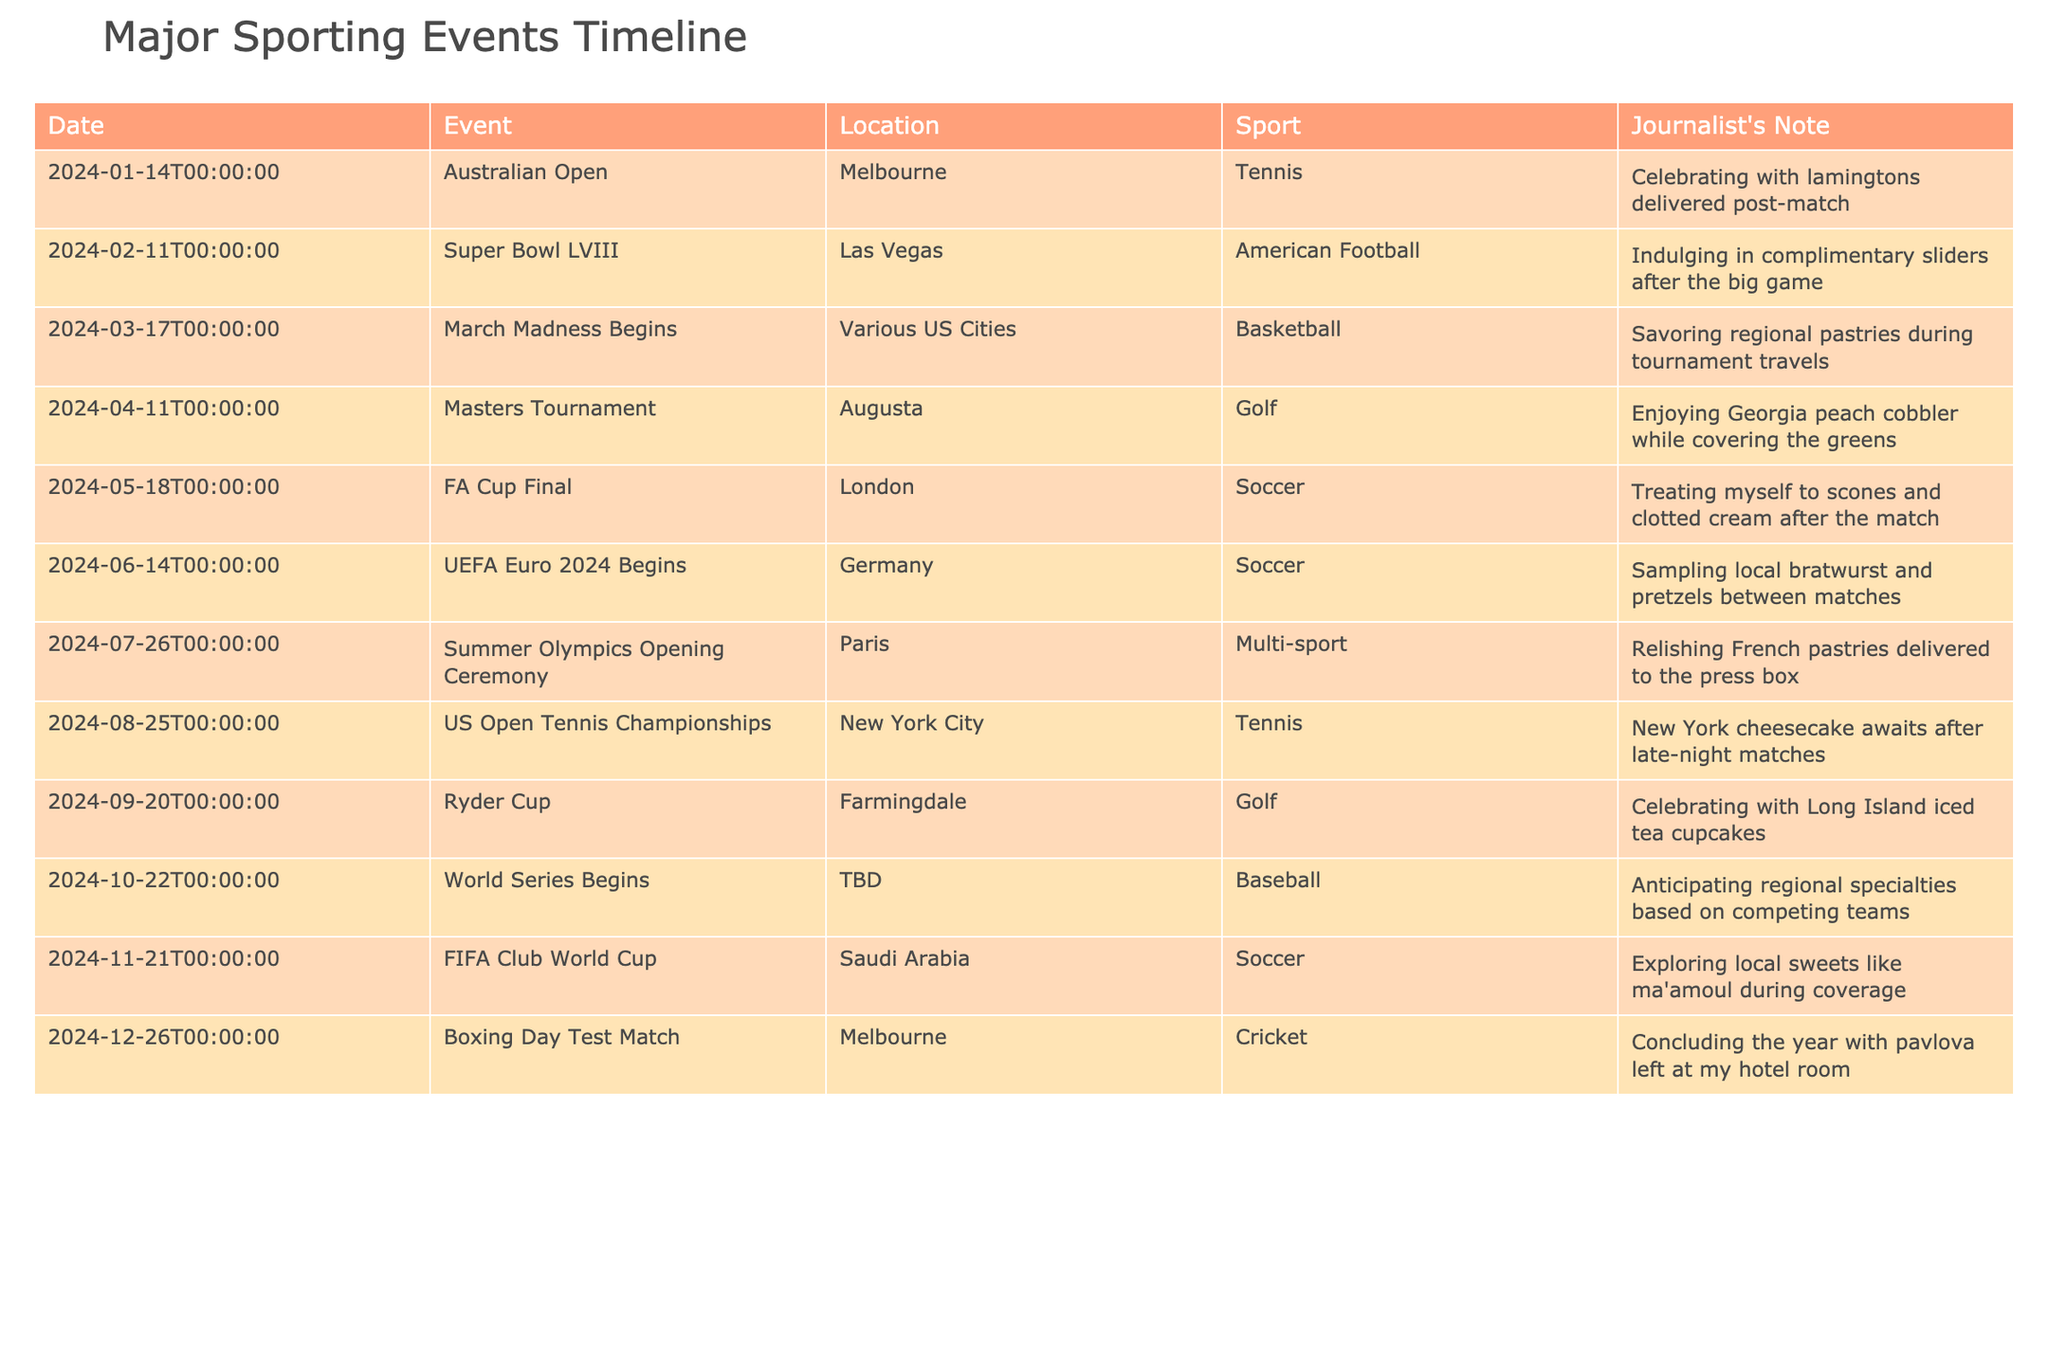What's the date of the Australian Open? The table shows that the Australian Open is scheduled for January 14, 2024.
Answer: January 14, 2024 In which sport does the Masters Tournament take place? According to the table, the Masters Tournament is categorized under the sport of Golf.
Answer: Golf How many events are scheduled in June 2024? The table lists one event in June, which is the UEFA Euro 2024, scheduled for June 14, 2024.
Answer: 1 What is the total number of events listed in the table? By counting each event listed in the table, there are a total of 12 major sporting events scheduled for the upcoming year.
Answer: 12 Is the FIFA Club World Cup taking place in the United States? The table indicates that the FIFA Club World Cup is being held in Saudi Arabia, therefore it is not taking place in the United States.
Answer: No Which event occurs closest to the end of the year? According to the table, the Boxing Day Test Match on December 26, 2024, is the event scheduled closest to the end of the year.
Answer: December 26, 2024 How many events are American Football related in this timeline? There is only one event related to American Football, which is the Super Bowl LVIII on February 11, 2024.
Answer: 1 Which month has the most events scheduled? By analyzing the table, it appears that June has only one event, but no month has highlighted multiple events. Therefore, the response must be checked for any month that could have equal events. Since all other months also show a single event, no month stands out in terms of quantity.
Answer: None What sport is associated with the event taking place in Paris? The Summer Olympics Opening Ceremony, happening in Paris, is classified under Multi-sport in the table.
Answer: Multi-sport 